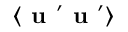Convert formula to latex. <formula><loc_0><loc_0><loc_500><loc_500>\langle { { u } ^ { \prime } { u } ^ { \prime } } \rangle</formula> 